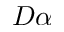Convert formula to latex. <formula><loc_0><loc_0><loc_500><loc_500>D \alpha</formula> 